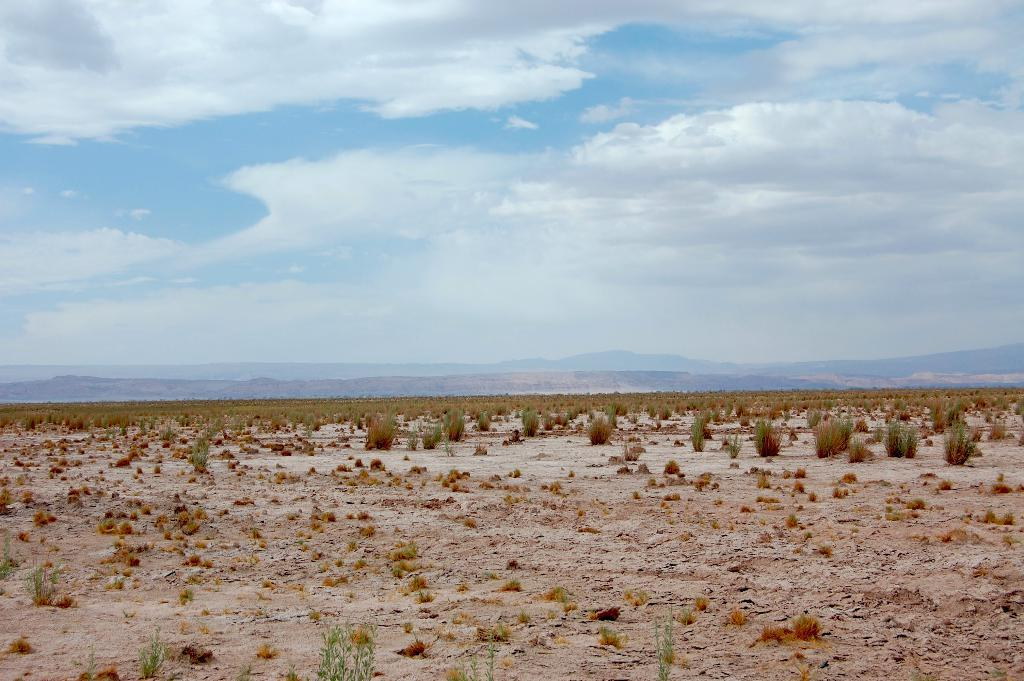What type of vegetation can be seen in the image? There are plants and grass visible in the image. What can be seen in the background of the image? Hills and a cloudy sky are visible in the background of the image. What type of steel structure can be seen in the image? There is no steel structure present in the image; it features plants, grass, hills, and a cloudy sky. How many snails are visible on the plants in the image? There are no snails visible on the plants in the image. 